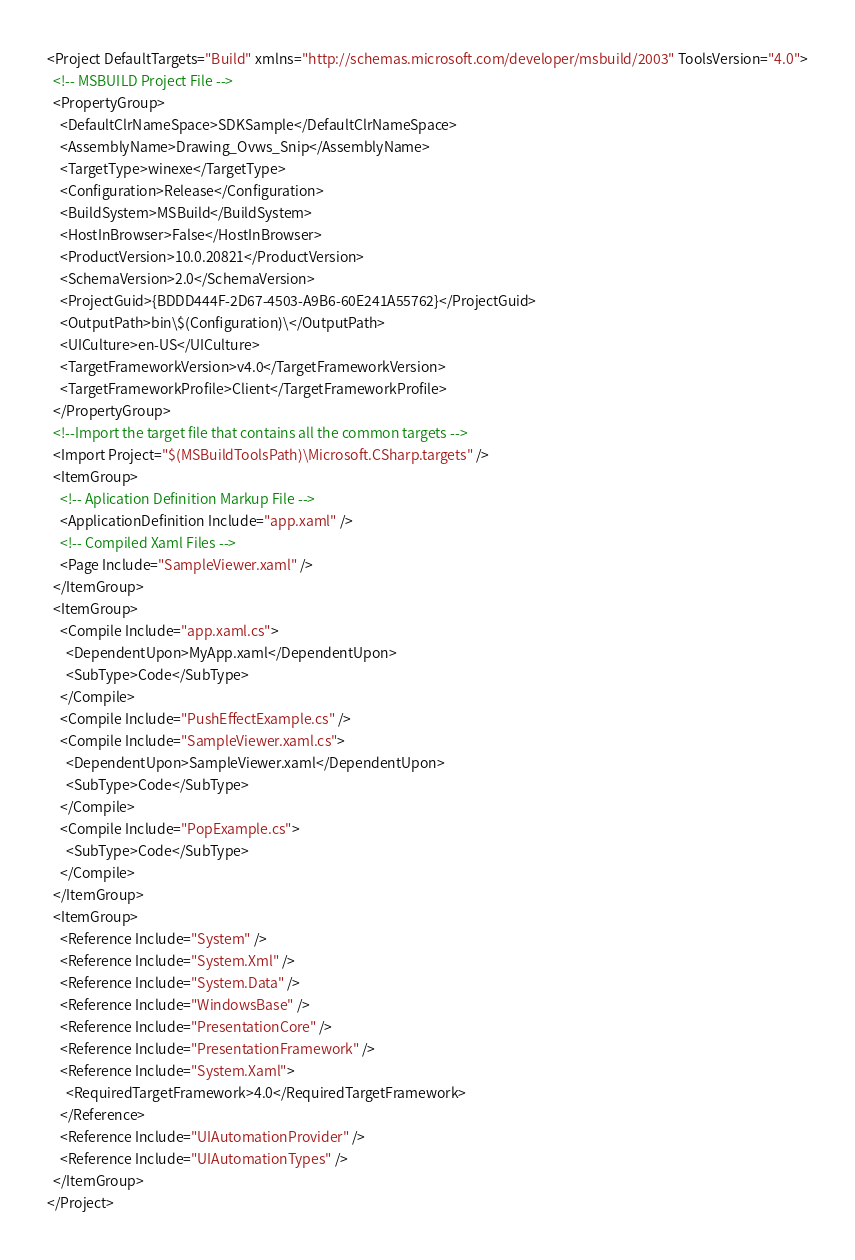Convert code to text. <code><loc_0><loc_0><loc_500><loc_500><_XML_><Project DefaultTargets="Build" xmlns="http://schemas.microsoft.com/developer/msbuild/2003" ToolsVersion="4.0">
  <!-- MSBUILD Project File -->
  <PropertyGroup>
    <DefaultClrNameSpace>SDKSample</DefaultClrNameSpace>
    <AssemblyName>Drawing_Ovws_Snip</AssemblyName>
    <TargetType>winexe</TargetType>
    <Configuration>Release</Configuration>
    <BuildSystem>MSBuild</BuildSystem>
    <HostInBrowser>False</HostInBrowser>
    <ProductVersion>10.0.20821</ProductVersion>
    <SchemaVersion>2.0</SchemaVersion>
    <ProjectGuid>{BDDD444F-2D67-4503-A9B6-60E241A55762}</ProjectGuid>
    <OutputPath>bin\$(Configuration)\</OutputPath>
    <UICulture>en-US</UICulture>
    <TargetFrameworkVersion>v4.0</TargetFrameworkVersion>
    <TargetFrameworkProfile>Client</TargetFrameworkProfile>
  </PropertyGroup>
  <!--Import the target file that contains all the common targets -->
  <Import Project="$(MSBuildToolsPath)\Microsoft.CSharp.targets" />
  <ItemGroup>
    <!-- Aplication Definition Markup File -->
    <ApplicationDefinition Include="app.xaml" />
    <!-- Compiled Xaml Files -->
    <Page Include="SampleViewer.xaml" />
  </ItemGroup>
  <ItemGroup>
    <Compile Include="app.xaml.cs">
      <DependentUpon>MyApp.xaml</DependentUpon>
      <SubType>Code</SubType>
    </Compile>
    <Compile Include="PushEffectExample.cs" />
    <Compile Include="SampleViewer.xaml.cs">
      <DependentUpon>SampleViewer.xaml</DependentUpon>
      <SubType>Code</SubType>
    </Compile>
    <Compile Include="PopExample.cs">
      <SubType>Code</SubType>
    </Compile>
  </ItemGroup>
  <ItemGroup>
    <Reference Include="System" />
    <Reference Include="System.Xml" />
    <Reference Include="System.Data" />
    <Reference Include="WindowsBase" />
    <Reference Include="PresentationCore" />
    <Reference Include="PresentationFramework" />
    <Reference Include="System.Xaml">
      <RequiredTargetFramework>4.0</RequiredTargetFramework>
    </Reference>
    <Reference Include="UIAutomationProvider" />
    <Reference Include="UIAutomationTypes" />
  </ItemGroup>
</Project></code> 